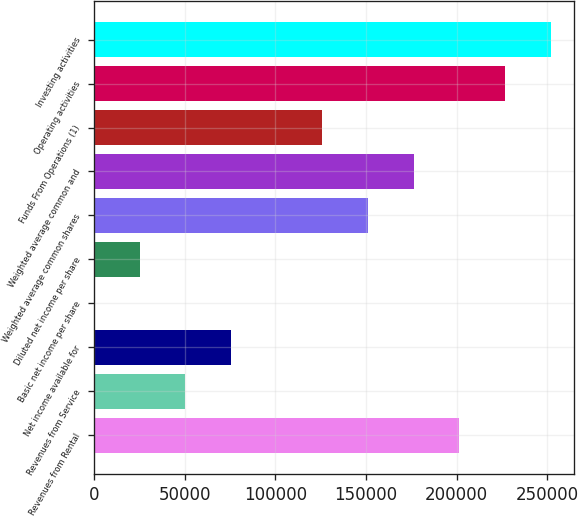Convert chart to OTSL. <chart><loc_0><loc_0><loc_500><loc_500><bar_chart><fcel>Revenues from Rental<fcel>Revenues from Service<fcel>Net income available for<fcel>Basic net income per share<fcel>Diluted net income per share<fcel>Weighted average common shares<fcel>Weighted average common and<fcel>Funds From Operations (1)<fcel>Operating activities<fcel>Investing activities<nl><fcel>201458<fcel>50364.7<fcel>75546.9<fcel>0.35<fcel>25182.5<fcel>151093<fcel>176276<fcel>125911<fcel>226640<fcel>251822<nl></chart> 